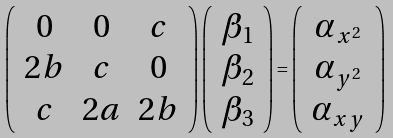<formula> <loc_0><loc_0><loc_500><loc_500>\left ( \begin{array} { c c c } 0 & 0 & c \\ 2 b & c & 0 \\ c & 2 a & 2 b \end{array} \right ) \left ( \begin{array} { c } \beta _ { 1 } \\ \beta _ { 2 } \\ \beta _ { 3 } \end{array} \right ) = \left ( \begin{array} { c } \alpha _ { x ^ { 2 } } \\ \alpha _ { y ^ { 2 } } \\ \alpha _ { x y } \end{array} \right )</formula> 